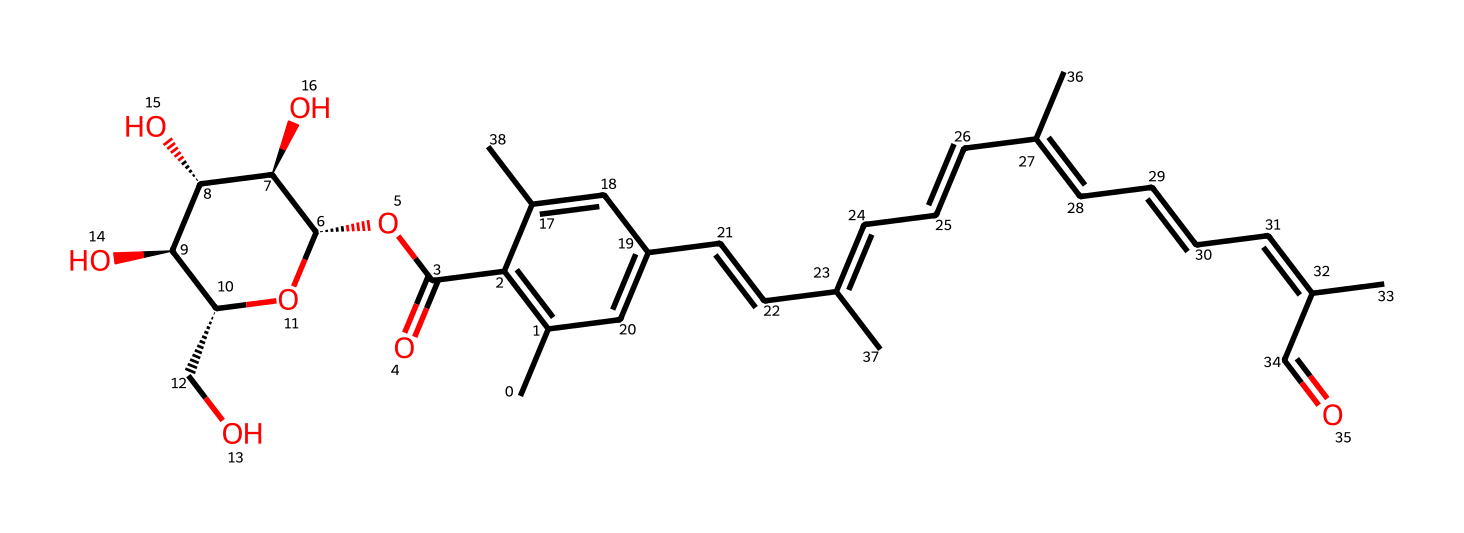What is the molecular formula of saffron? By examining the SMILES representation, we can deduce the number of carbon (C), hydrogen (H), and oxygen (O) atoms present in the structure. Count the atoms based on the representation, and we find a total of 28 carbon atoms, 38 hydrogen atoms, and 6 oxygen atoms. Therefore, the molecular formula is C28H38O6.
Answer: C28H38O6 How many rings are present in the saffron structure? Analyzing the SMILES shows multiple cycles of carbon atoms (rings). By visual identification, there is a total of 2 distinct rings in the chemical structure.
Answer: 2 What functional groups are present in saffron? Examining the structure allows us to identify various functional groups. Notably, the hydroxyl (-OH) groups and the carboxylic acid (-COOH) group are evident in the structure. Thus, the presence of these functional groups indicates polarity and potential solubility characteristics in different solvents.
Answer: hydroxyl and carboxylic acid Is saffron a polar or non-polar compound? The presence of multiple hydroxyl (-OH) groups contributes significant polarity to the molecule, enabling the saffron compound to engage in hydrogen bonding. Therefore, considering the overall structure's distribution of hydrophilic regions due to these functional groups, saffron is classified as a polar compound.
Answer: polar What is the predominant type of bonding in saffron? Looking at the structure, we can determine that the majority of the bonding is covalent. Covalent bonds are primarily formed between the carbon and hydrogen atoms, as well as between carbon and oxygen atoms throughout the molecule. Thus, it can be concluded that the structure features predominantly covalent bonding.
Answer: covalent What feature of saffron contributes to its color? The complex arrangement of double bonds within the rings (conjugated system) is responsible for the absorption of specific light wavelengths, which leads to the characteristic color of saffron. This absorption impacts how the dye interacts visually when used in various applications, making it a valuable ingredient in both culinary and artistic contexts.
Answer: conjugated system 